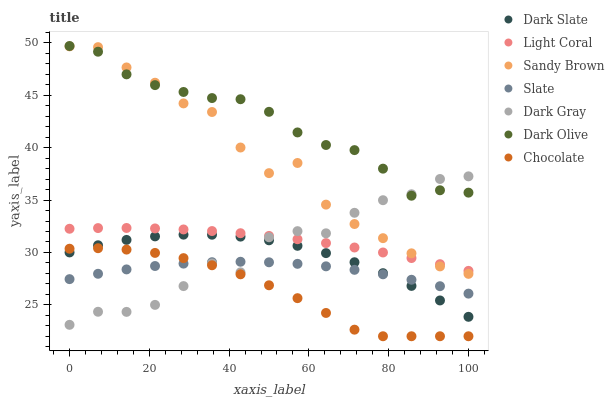Does Chocolate have the minimum area under the curve?
Answer yes or no. Yes. Does Dark Olive have the maximum area under the curve?
Answer yes or no. Yes. Does Slate have the minimum area under the curve?
Answer yes or no. No. Does Slate have the maximum area under the curve?
Answer yes or no. No. Is Light Coral the smoothest?
Answer yes or no. Yes. Is Dark Gray the roughest?
Answer yes or no. Yes. Is Slate the smoothest?
Answer yes or no. No. Is Slate the roughest?
Answer yes or no. No. Does Chocolate have the lowest value?
Answer yes or no. Yes. Does Slate have the lowest value?
Answer yes or no. No. Does Dark Olive have the highest value?
Answer yes or no. Yes. Does Slate have the highest value?
Answer yes or no. No. Is Slate less than Light Coral?
Answer yes or no. Yes. Is Dark Olive greater than Light Coral?
Answer yes or no. Yes. Does Sandy Brown intersect Dark Gray?
Answer yes or no. Yes. Is Sandy Brown less than Dark Gray?
Answer yes or no. No. Is Sandy Brown greater than Dark Gray?
Answer yes or no. No. Does Slate intersect Light Coral?
Answer yes or no. No. 